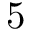<formula> <loc_0><loc_0><loc_500><loc_500>5</formula> 